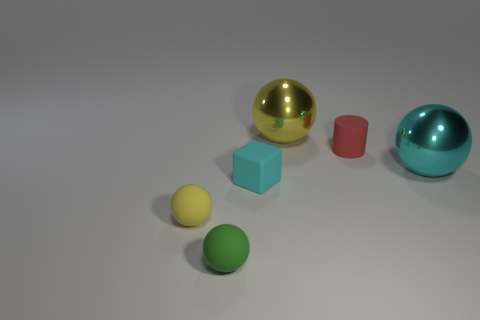Is there any other thing that has the same color as the cylinder?
Your answer should be compact. No. There is a matte cylinder that is the same size as the matte cube; what is its color?
Ensure brevity in your answer.  Red. What number of cylinders are there?
Your response must be concise. 1. Do the sphere right of the tiny cylinder and the small cyan thing have the same material?
Provide a succinct answer. No. What is the material of the small object that is both behind the small green matte ball and to the left of the cyan block?
Give a very brief answer. Rubber. There is a ball that is the same color as the tiny cube; what is its size?
Keep it short and to the point. Large. The tiny thing that is behind the cyan object left of the large cyan shiny object is made of what material?
Your answer should be compact. Rubber. What size is the yellow object on the right side of the yellow matte thing left of the rubber ball that is in front of the yellow rubber object?
Offer a terse response. Large. How many tiny brown things are made of the same material as the small green sphere?
Provide a short and direct response. 0. The tiny matte ball in front of the yellow object to the left of the green ball is what color?
Offer a terse response. Green. 